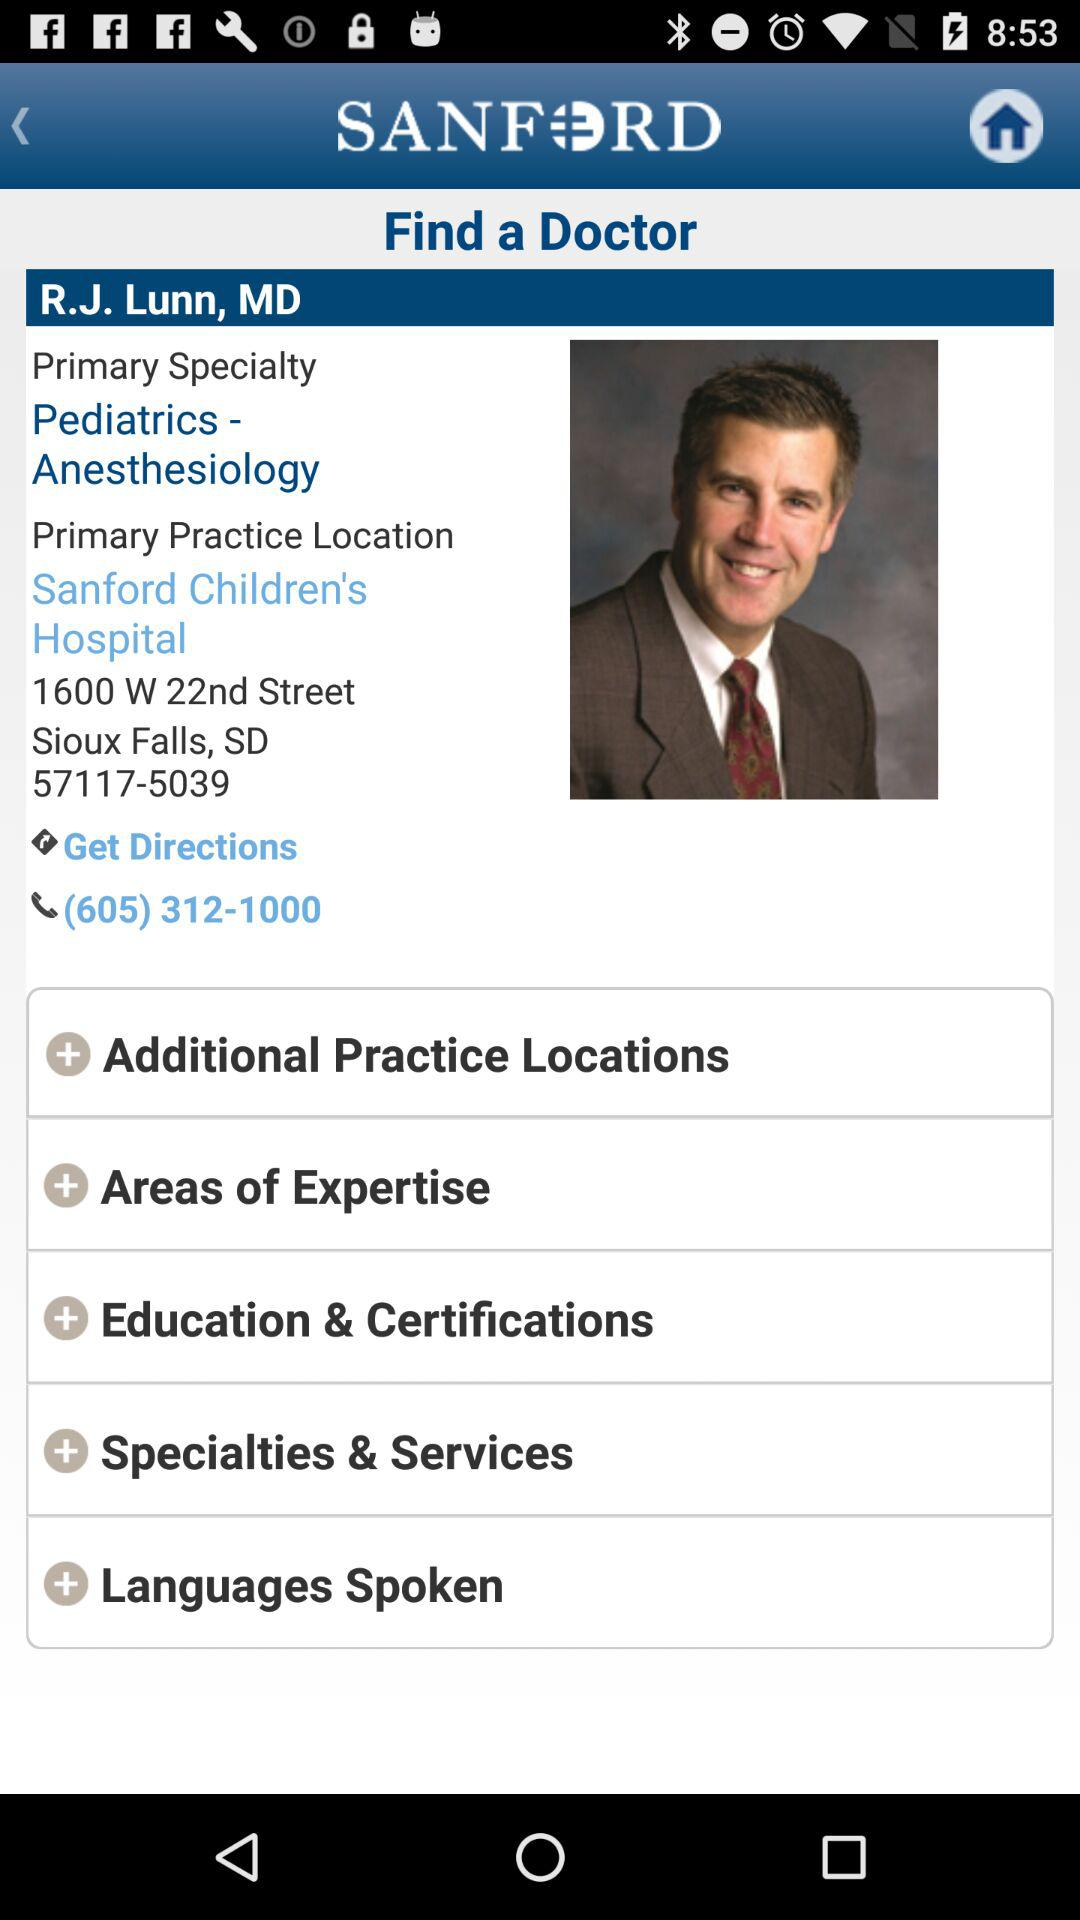What is the name of the doctor? The name of the doctor is R.J. Lunn. 